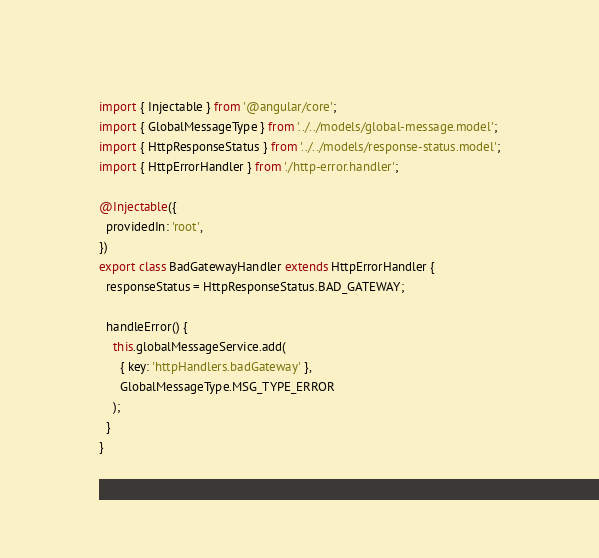<code> <loc_0><loc_0><loc_500><loc_500><_TypeScript_>import { Injectable } from '@angular/core';
import { GlobalMessageType } from '../../models/global-message.model';
import { HttpResponseStatus } from '../../models/response-status.model';
import { HttpErrorHandler } from './http-error.handler';

@Injectable({
  providedIn: 'root',
})
export class BadGatewayHandler extends HttpErrorHandler {
  responseStatus = HttpResponseStatus.BAD_GATEWAY;

  handleError() {
    this.globalMessageService.add(
      { key: 'httpHandlers.badGateway' },
      GlobalMessageType.MSG_TYPE_ERROR
    );
  }
}
</code> 